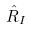Convert formula to latex. <formula><loc_0><loc_0><loc_500><loc_500>\hat { R } _ { I }</formula> 